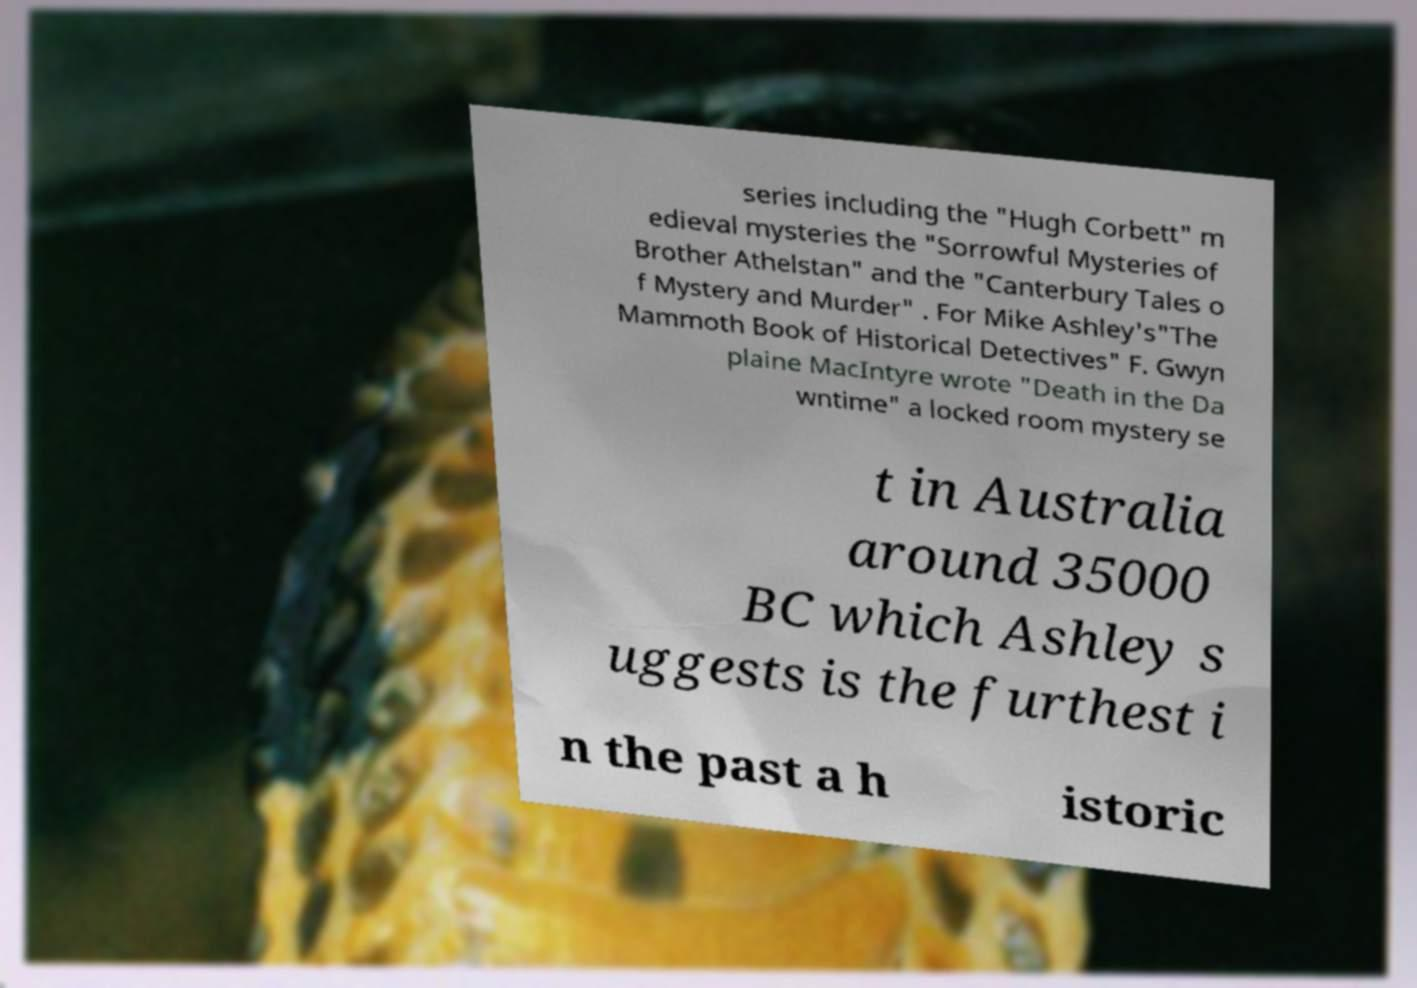Please read and relay the text visible in this image. What does it say? series including the "Hugh Corbett" m edieval mysteries the "Sorrowful Mysteries of Brother Athelstan" and the "Canterbury Tales o f Mystery and Murder" . For Mike Ashley's"The Mammoth Book of Historical Detectives" F. Gwyn plaine MacIntyre wrote "Death in the Da wntime" a locked room mystery se t in Australia around 35000 BC which Ashley s uggests is the furthest i n the past a h istoric 